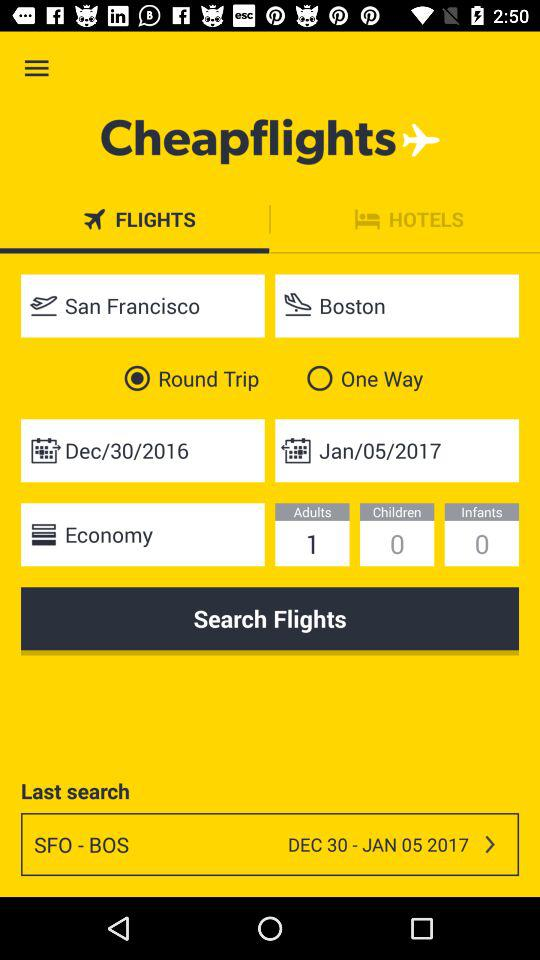What is the application name? The application name is "Cheapflights". 